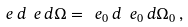<formula> <loc_0><loc_0><loc_500><loc_500>\ e \, d \ e \, d \Omega = \ e _ { 0 } \, d \ e _ { 0 } \, d \Omega _ { 0 } \, ,</formula> 